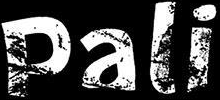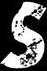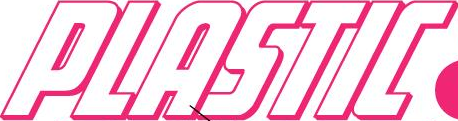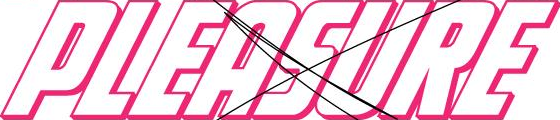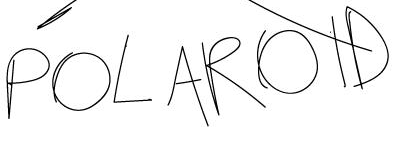Transcribe the words shown in these images in order, separated by a semicolon. Pali; s; PLASTIC; PLEASURE; POLAROID 